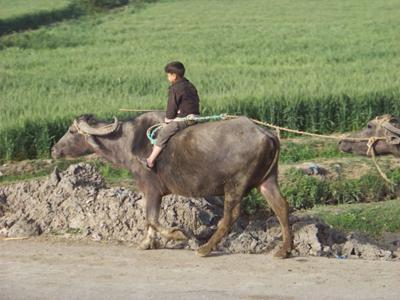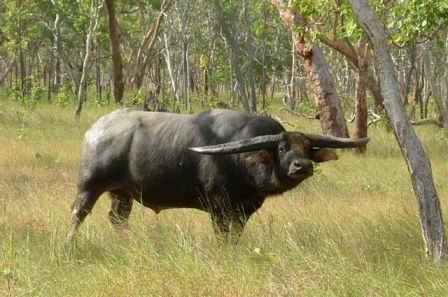The first image is the image on the left, the second image is the image on the right. Analyze the images presented: Is the assertion "There is at least one person in each image with a water buffalo." valid? Answer yes or no. No. The first image is the image on the left, the second image is the image on the right. Considering the images on both sides, is "Only one of the images contains a sole rider on a water buffalo." valid? Answer yes or no. Yes. 